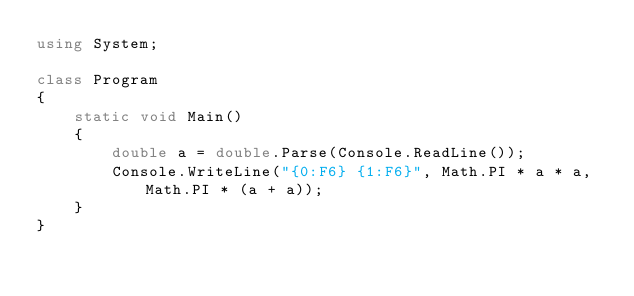<code> <loc_0><loc_0><loc_500><loc_500><_C#_>using System;

class Program
{
	static void Main()
	{
		double a = double.Parse(Console.ReadLine());
		Console.WriteLine("{0:F6} {1:F6}", Math.PI * a * a, Math.PI * (a + a));
	}
}</code> 